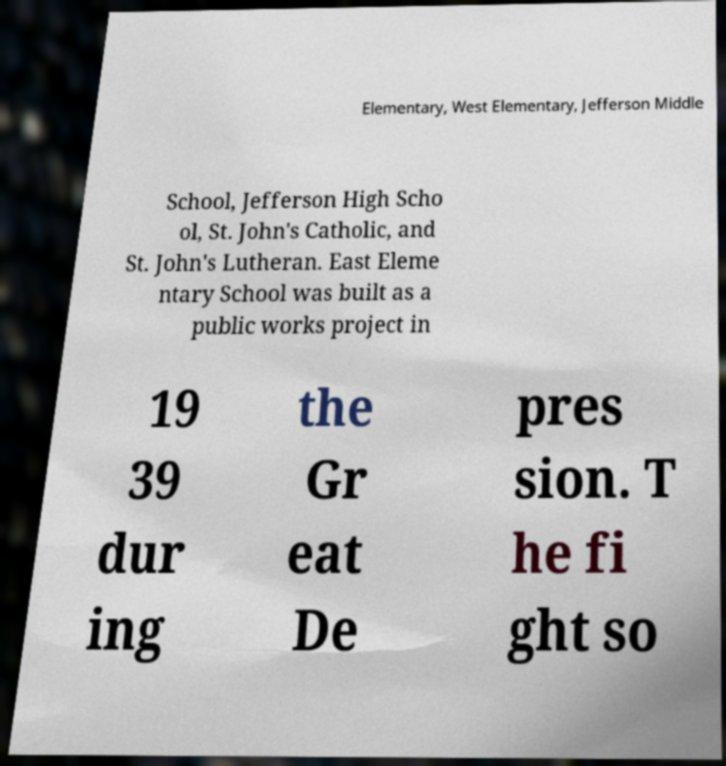Could you extract and type out the text from this image? Elementary, West Elementary, Jefferson Middle School, Jefferson High Scho ol, St. John's Catholic, and St. John's Lutheran. East Eleme ntary School was built as a public works project in 19 39 dur ing the Gr eat De pres sion. T he fi ght so 